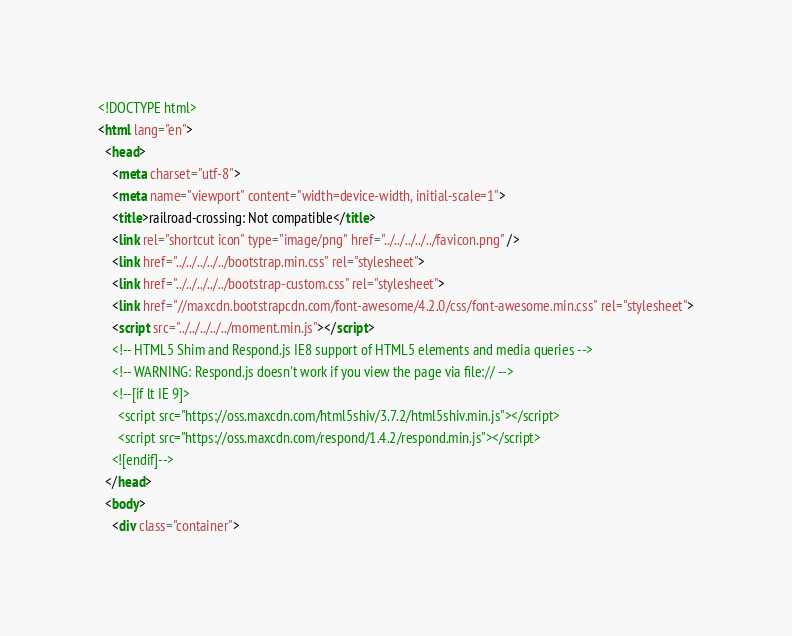Convert code to text. <code><loc_0><loc_0><loc_500><loc_500><_HTML_><!DOCTYPE html>
<html lang="en">
  <head>
    <meta charset="utf-8">
    <meta name="viewport" content="width=device-width, initial-scale=1">
    <title>railroad-crossing: Not compatible</title>
    <link rel="shortcut icon" type="image/png" href="../../../../../favicon.png" />
    <link href="../../../../../bootstrap.min.css" rel="stylesheet">
    <link href="../../../../../bootstrap-custom.css" rel="stylesheet">
    <link href="//maxcdn.bootstrapcdn.com/font-awesome/4.2.0/css/font-awesome.min.css" rel="stylesheet">
    <script src="../../../../../moment.min.js"></script>
    <!-- HTML5 Shim and Respond.js IE8 support of HTML5 elements and media queries -->
    <!-- WARNING: Respond.js doesn't work if you view the page via file:// -->
    <!--[if lt IE 9]>
      <script src="https://oss.maxcdn.com/html5shiv/3.7.2/html5shiv.min.js"></script>
      <script src="https://oss.maxcdn.com/respond/1.4.2/respond.min.js"></script>
    <![endif]-->
  </head>
  <body>
    <div class="container"></code> 